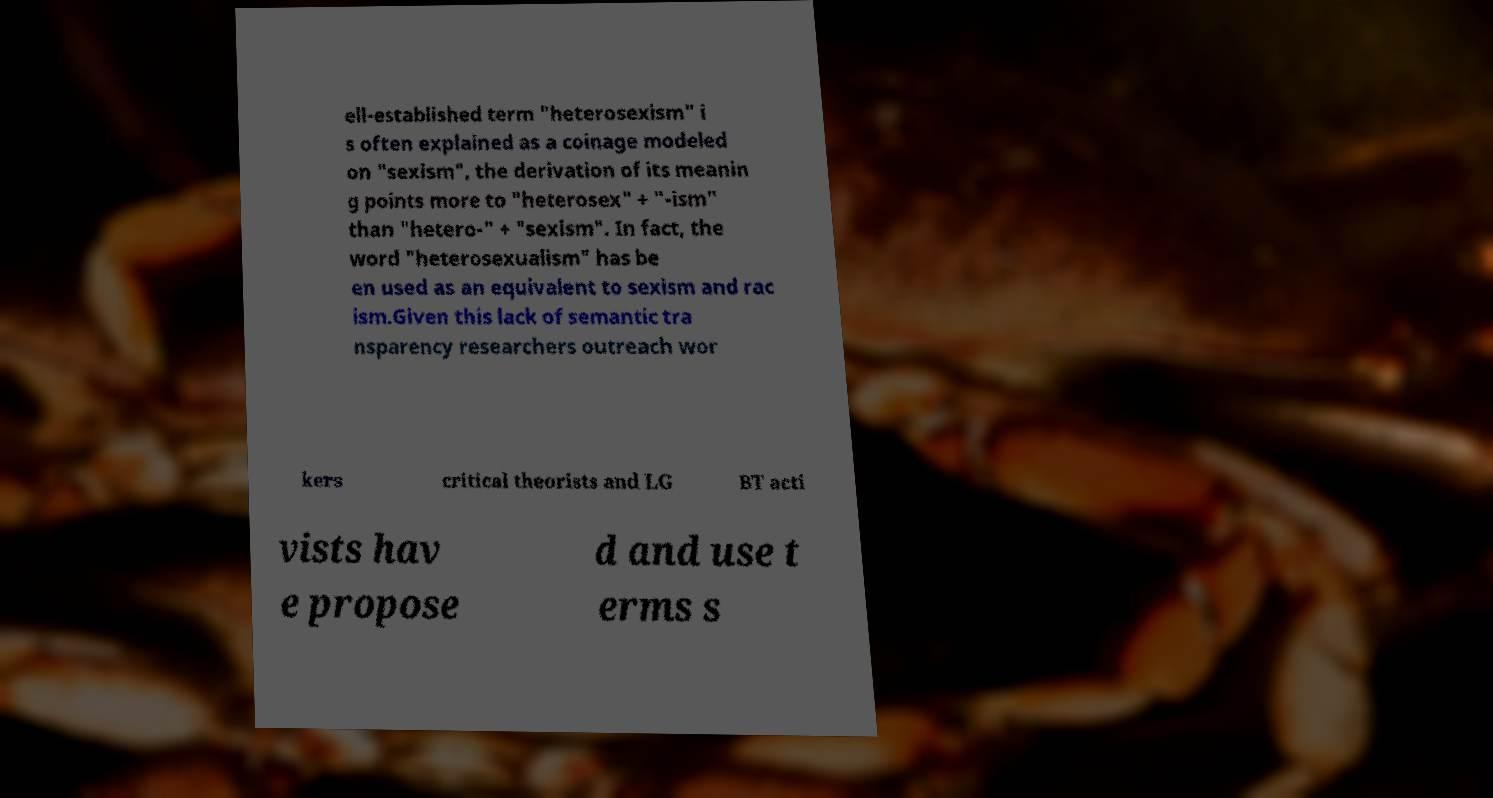Can you accurately transcribe the text from the provided image for me? ell-established term "heterosexism" i s often explained as a coinage modeled on "sexism", the derivation of its meanin g points more to "heterosex" + "-ism" than "hetero-" + "sexism". In fact, the word "heterosexualism" has be en used as an equivalent to sexism and rac ism.Given this lack of semantic tra nsparency researchers outreach wor kers critical theorists and LG BT acti vists hav e propose d and use t erms s 